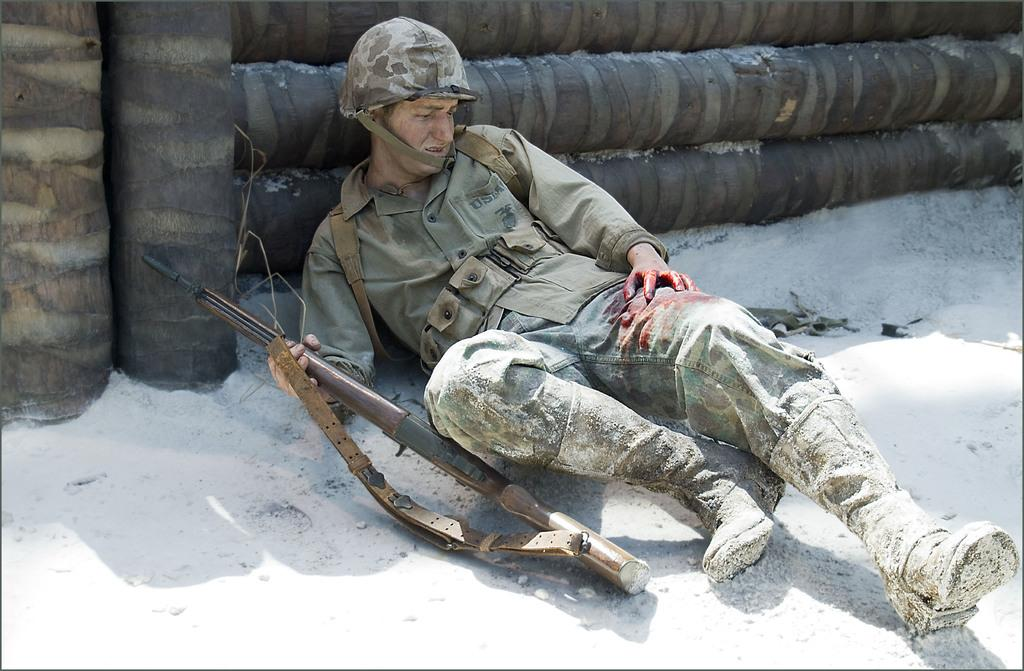What is the person in the image wearing? The person is wearing a military uniform and a helmet. What is the person holding in their hand? The person is holding a gun in their hand. What position is the person in? The person is lying on the ground. What can be seen in the background of the image? There are wood logs in the background of the image. What type of beef can be seen cooking on a grill in the image? There is no beef or grill present in the image; it features a person in a military uniform lying on the ground with a gun and wood logs in the background. 